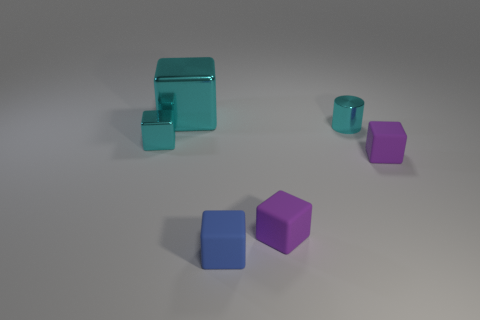There is a metallic object that is behind the cyan metal cylinder; does it have the same color as the shiny thing on the right side of the big object?
Your response must be concise. Yes. Is there any other thing that has the same color as the tiny metallic cylinder?
Your response must be concise. Yes. What is the color of the small metal cube?
Give a very brief answer. Cyan. Are any big blue shiny things visible?
Make the answer very short. No. There is a big cyan metallic object; are there any big cubes in front of it?
Give a very brief answer. No. There is a big cyan thing that is the same shape as the blue thing; what is its material?
Your answer should be very brief. Metal. How many other objects are there of the same shape as the blue rubber object?
Offer a terse response. 4. There is a small cyan thing that is on the right side of the small metallic object that is in front of the cyan cylinder; how many small blue objects are behind it?
Your answer should be compact. 0. What number of tiny purple matte things are the same shape as the big cyan metallic thing?
Provide a succinct answer. 2. There is a block on the left side of the large metallic thing; is it the same color as the shiny cylinder?
Your response must be concise. Yes. 